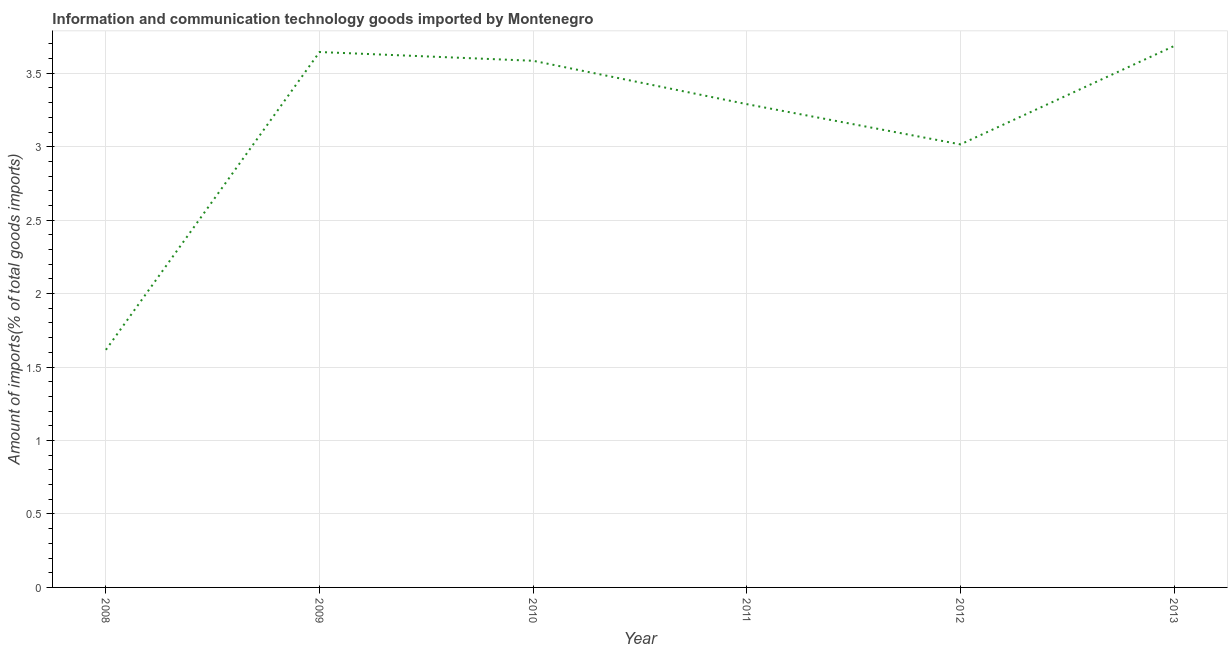What is the amount of ict goods imports in 2011?
Give a very brief answer. 3.29. Across all years, what is the maximum amount of ict goods imports?
Keep it short and to the point. 3.69. Across all years, what is the minimum amount of ict goods imports?
Your answer should be very brief. 1.62. In which year was the amount of ict goods imports maximum?
Provide a succinct answer. 2013. In which year was the amount of ict goods imports minimum?
Give a very brief answer. 2008. What is the sum of the amount of ict goods imports?
Provide a succinct answer. 18.84. What is the difference between the amount of ict goods imports in 2008 and 2009?
Ensure brevity in your answer.  -2.03. What is the average amount of ict goods imports per year?
Provide a short and direct response. 3.14. What is the median amount of ict goods imports?
Give a very brief answer. 3.44. In how many years, is the amount of ict goods imports greater than 1.4 %?
Your answer should be very brief. 6. Do a majority of the years between 2009 and 2008 (inclusive) have amount of ict goods imports greater than 0.30000000000000004 %?
Provide a short and direct response. No. What is the ratio of the amount of ict goods imports in 2012 to that in 2013?
Give a very brief answer. 0.82. Is the difference between the amount of ict goods imports in 2008 and 2010 greater than the difference between any two years?
Provide a short and direct response. No. What is the difference between the highest and the second highest amount of ict goods imports?
Your answer should be compact. 0.04. Is the sum of the amount of ict goods imports in 2012 and 2013 greater than the maximum amount of ict goods imports across all years?
Make the answer very short. Yes. What is the difference between the highest and the lowest amount of ict goods imports?
Your answer should be compact. 2.07. In how many years, is the amount of ict goods imports greater than the average amount of ict goods imports taken over all years?
Provide a short and direct response. 4. What is the difference between two consecutive major ticks on the Y-axis?
Give a very brief answer. 0.5. What is the title of the graph?
Offer a very short reply. Information and communication technology goods imported by Montenegro. What is the label or title of the X-axis?
Offer a very short reply. Year. What is the label or title of the Y-axis?
Provide a short and direct response. Amount of imports(% of total goods imports). What is the Amount of imports(% of total goods imports) of 2008?
Make the answer very short. 1.62. What is the Amount of imports(% of total goods imports) of 2009?
Keep it short and to the point. 3.64. What is the Amount of imports(% of total goods imports) of 2010?
Provide a succinct answer. 3.58. What is the Amount of imports(% of total goods imports) in 2011?
Keep it short and to the point. 3.29. What is the Amount of imports(% of total goods imports) of 2012?
Ensure brevity in your answer.  3.02. What is the Amount of imports(% of total goods imports) of 2013?
Ensure brevity in your answer.  3.69. What is the difference between the Amount of imports(% of total goods imports) in 2008 and 2009?
Your answer should be very brief. -2.03. What is the difference between the Amount of imports(% of total goods imports) in 2008 and 2010?
Offer a very short reply. -1.97. What is the difference between the Amount of imports(% of total goods imports) in 2008 and 2011?
Keep it short and to the point. -1.67. What is the difference between the Amount of imports(% of total goods imports) in 2008 and 2012?
Give a very brief answer. -1.4. What is the difference between the Amount of imports(% of total goods imports) in 2008 and 2013?
Make the answer very short. -2.07. What is the difference between the Amount of imports(% of total goods imports) in 2009 and 2010?
Offer a terse response. 0.06. What is the difference between the Amount of imports(% of total goods imports) in 2009 and 2011?
Give a very brief answer. 0.35. What is the difference between the Amount of imports(% of total goods imports) in 2009 and 2012?
Your answer should be very brief. 0.63. What is the difference between the Amount of imports(% of total goods imports) in 2009 and 2013?
Ensure brevity in your answer.  -0.04. What is the difference between the Amount of imports(% of total goods imports) in 2010 and 2011?
Offer a very short reply. 0.3. What is the difference between the Amount of imports(% of total goods imports) in 2010 and 2012?
Offer a very short reply. 0.57. What is the difference between the Amount of imports(% of total goods imports) in 2010 and 2013?
Your answer should be compact. -0.1. What is the difference between the Amount of imports(% of total goods imports) in 2011 and 2012?
Provide a succinct answer. 0.27. What is the difference between the Amount of imports(% of total goods imports) in 2011 and 2013?
Your response must be concise. -0.4. What is the difference between the Amount of imports(% of total goods imports) in 2012 and 2013?
Ensure brevity in your answer.  -0.67. What is the ratio of the Amount of imports(% of total goods imports) in 2008 to that in 2009?
Your response must be concise. 0.44. What is the ratio of the Amount of imports(% of total goods imports) in 2008 to that in 2010?
Give a very brief answer. 0.45. What is the ratio of the Amount of imports(% of total goods imports) in 2008 to that in 2011?
Offer a terse response. 0.49. What is the ratio of the Amount of imports(% of total goods imports) in 2008 to that in 2012?
Ensure brevity in your answer.  0.54. What is the ratio of the Amount of imports(% of total goods imports) in 2008 to that in 2013?
Your answer should be compact. 0.44. What is the ratio of the Amount of imports(% of total goods imports) in 2009 to that in 2010?
Provide a succinct answer. 1.02. What is the ratio of the Amount of imports(% of total goods imports) in 2009 to that in 2011?
Keep it short and to the point. 1.11. What is the ratio of the Amount of imports(% of total goods imports) in 2009 to that in 2012?
Provide a succinct answer. 1.21. What is the ratio of the Amount of imports(% of total goods imports) in 2010 to that in 2011?
Offer a very short reply. 1.09. What is the ratio of the Amount of imports(% of total goods imports) in 2010 to that in 2012?
Keep it short and to the point. 1.19. What is the ratio of the Amount of imports(% of total goods imports) in 2011 to that in 2012?
Your answer should be compact. 1.09. What is the ratio of the Amount of imports(% of total goods imports) in 2011 to that in 2013?
Ensure brevity in your answer.  0.89. What is the ratio of the Amount of imports(% of total goods imports) in 2012 to that in 2013?
Ensure brevity in your answer.  0.82. 